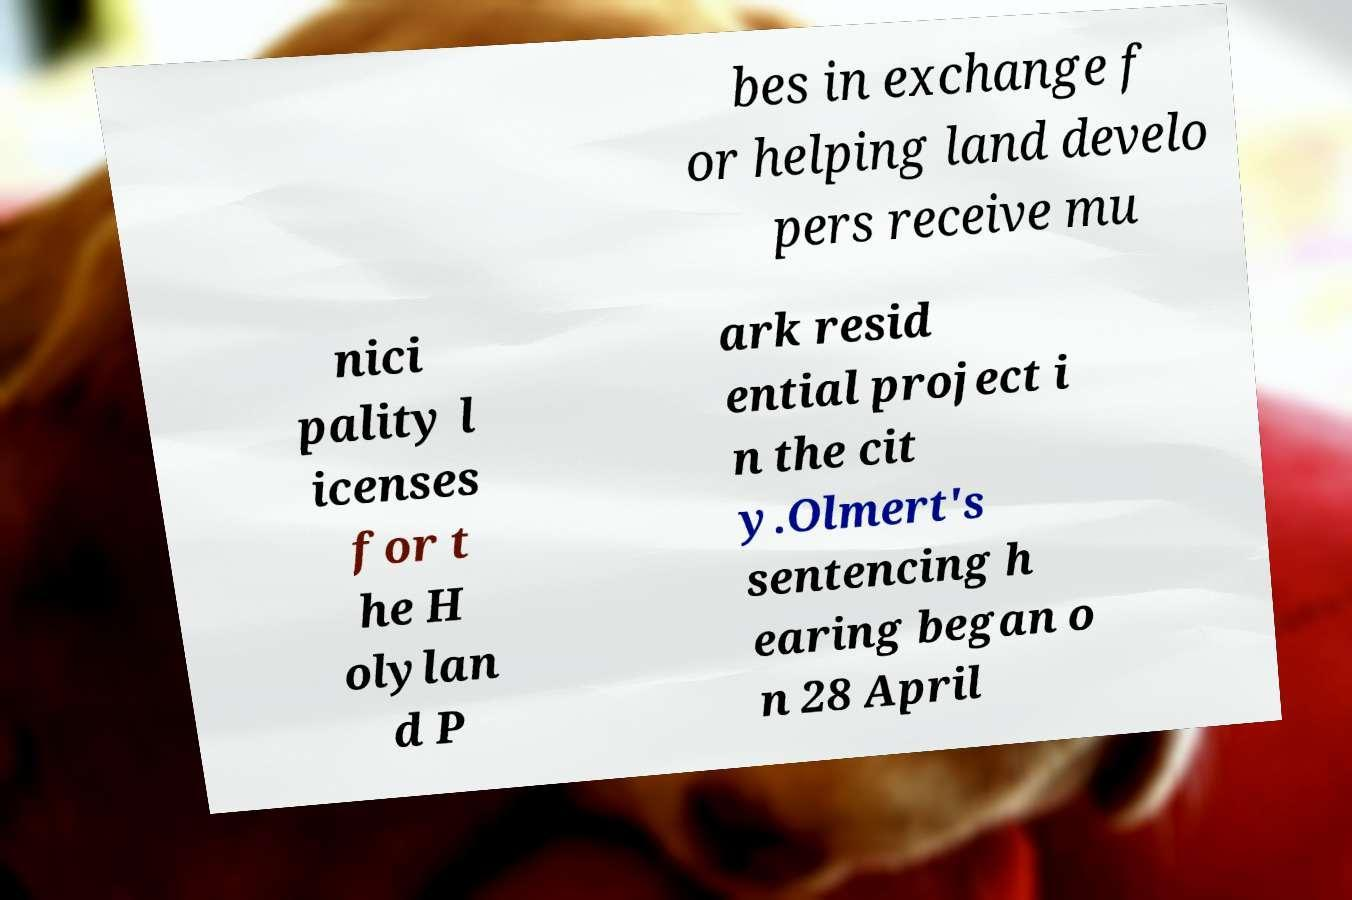There's text embedded in this image that I need extracted. Can you transcribe it verbatim? bes in exchange f or helping land develo pers receive mu nici pality l icenses for t he H olylan d P ark resid ential project i n the cit y.Olmert's sentencing h earing began o n 28 April 